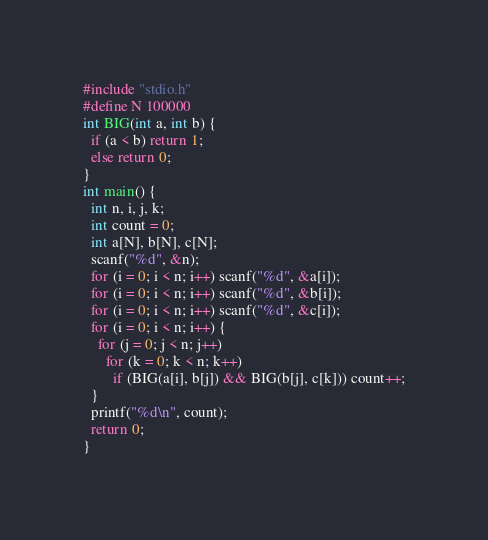<code> <loc_0><loc_0><loc_500><loc_500><_C_>#include "stdio.h"
#define N 100000
int BIG(int a, int b) {
  if (a < b) return 1;
  else return 0;
}
int main() {
  int n, i, j, k;
  int count = 0;
  int a[N], b[N], c[N];
  scanf("%d", &n);
  for (i = 0; i < n; i++) scanf("%d", &a[i]);
  for (i = 0; i < n; i++) scanf("%d", &b[i]);
  for (i = 0; i < n; i++) scanf("%d", &c[i]);
  for (i = 0; i < n; i++) {
    for (j = 0; j < n; j++)
      for (k = 0; k < n; k++)
        if (BIG(a[i], b[j]) && BIG(b[j], c[k])) count++;
  }
  printf("%d\n", count);
  return 0;
}
</code> 